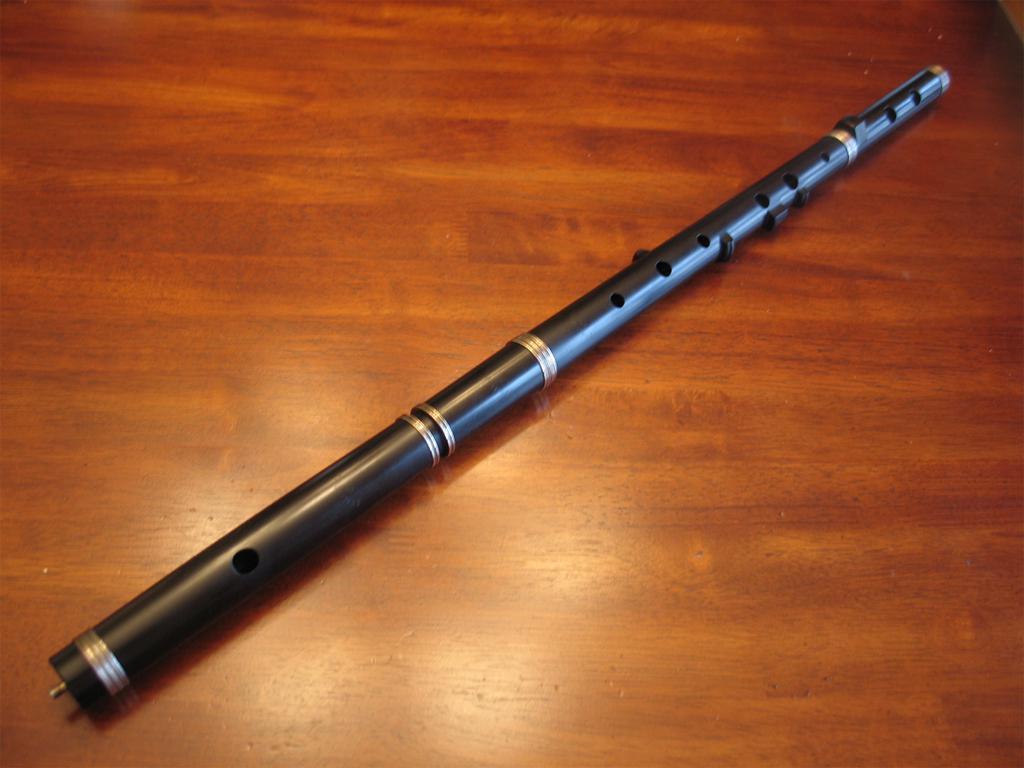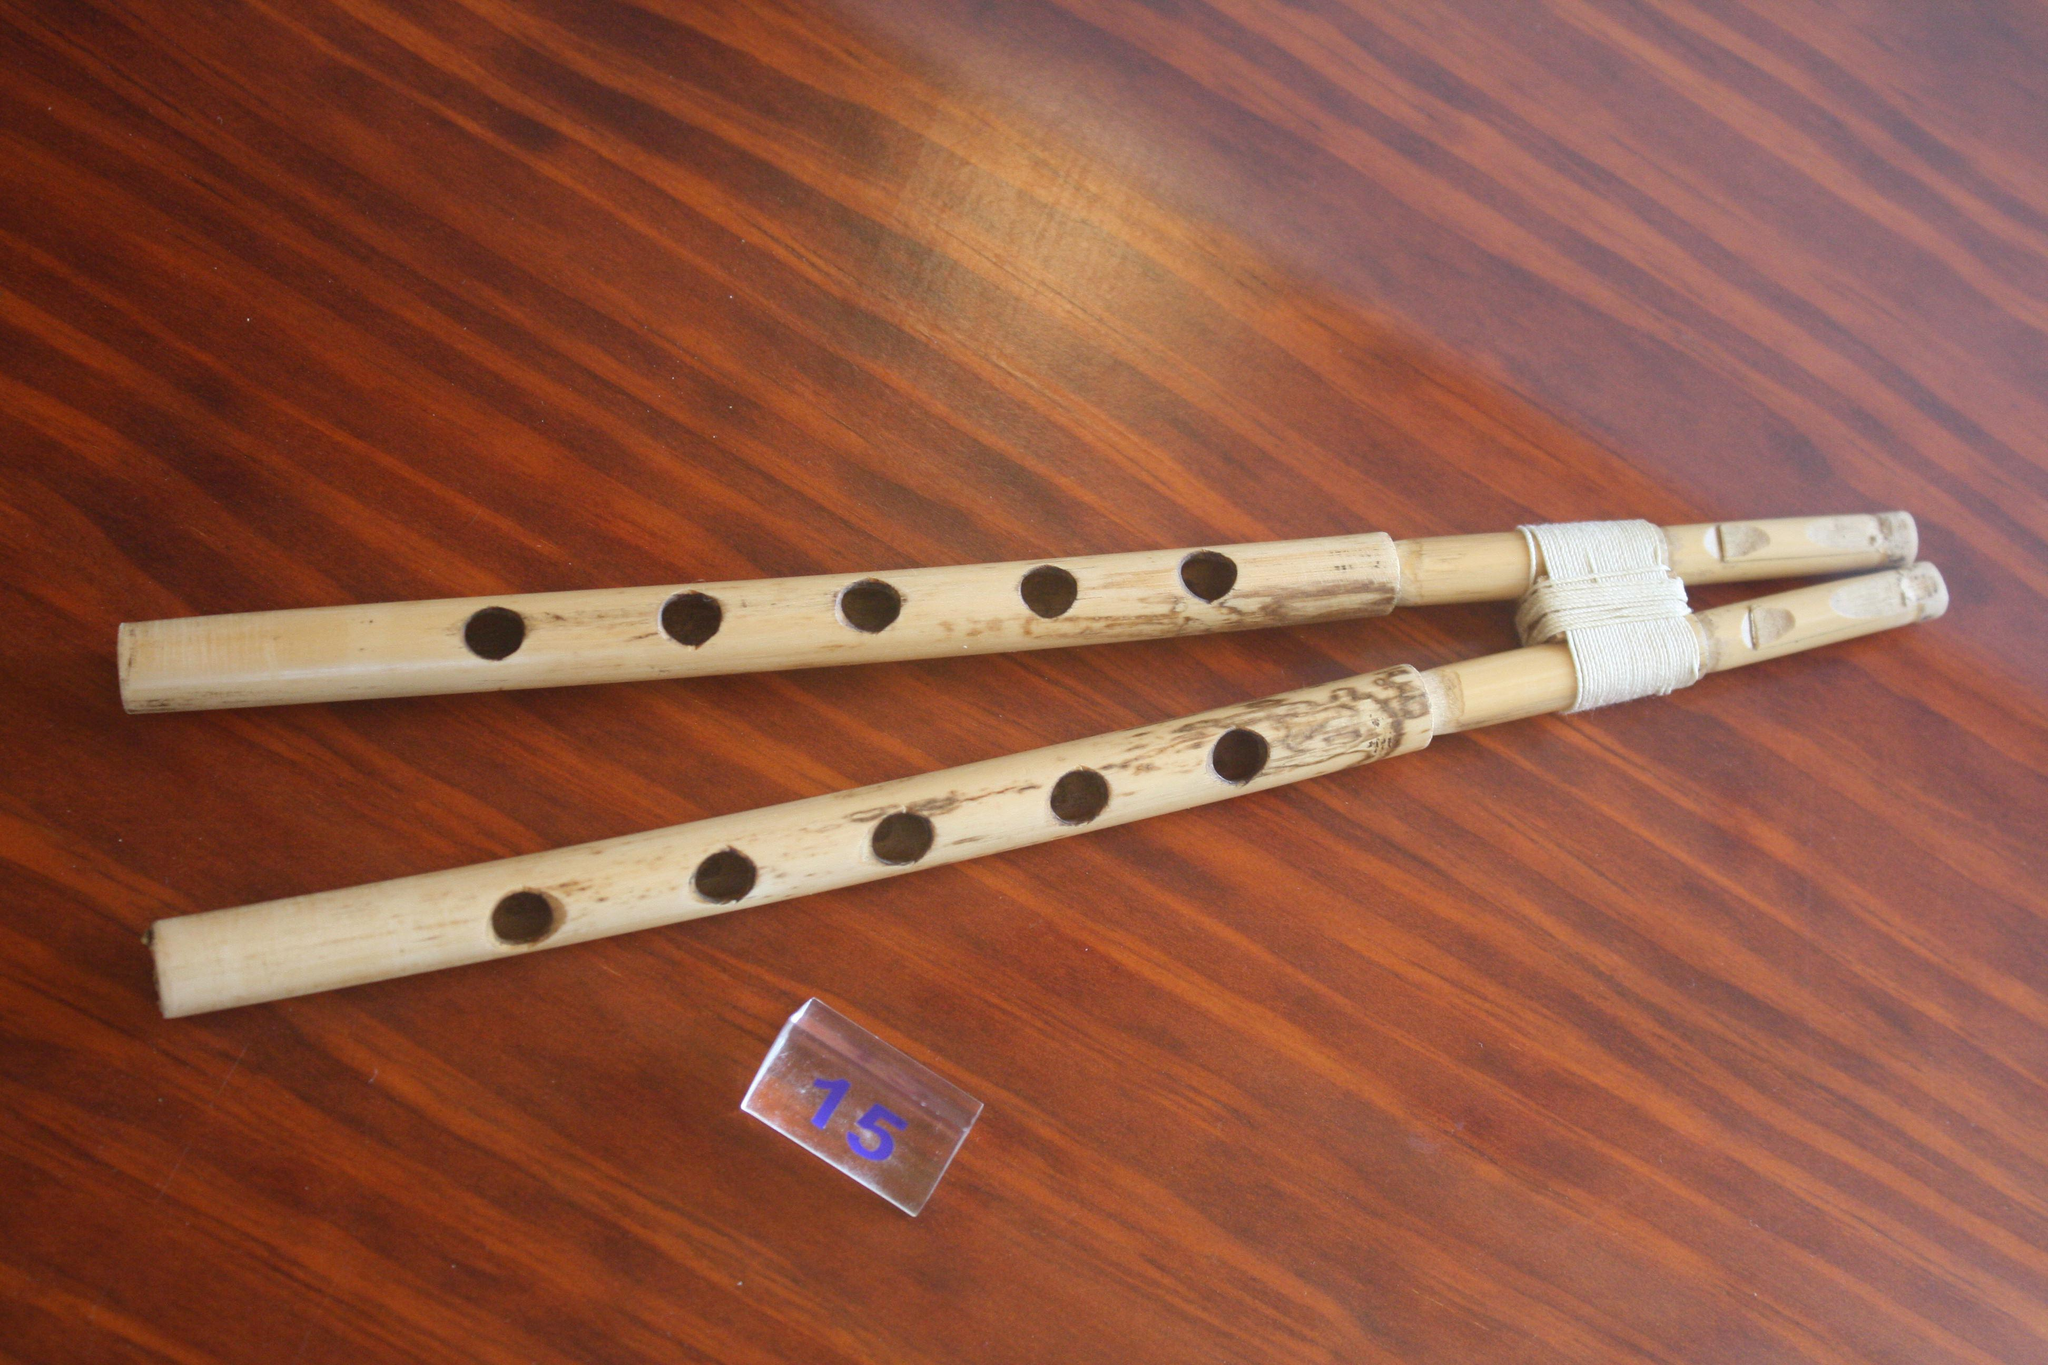The first image is the image on the left, the second image is the image on the right. Examine the images to the left and right. Is the description "One image contains at least two flute sticks positioned with one end together and the other end fanning out." accurate? Answer yes or no. Yes. The first image is the image on the left, the second image is the image on the right. Assess this claim about the two images: "There are exactly two flutes.". Correct or not? Answer yes or no. No. 